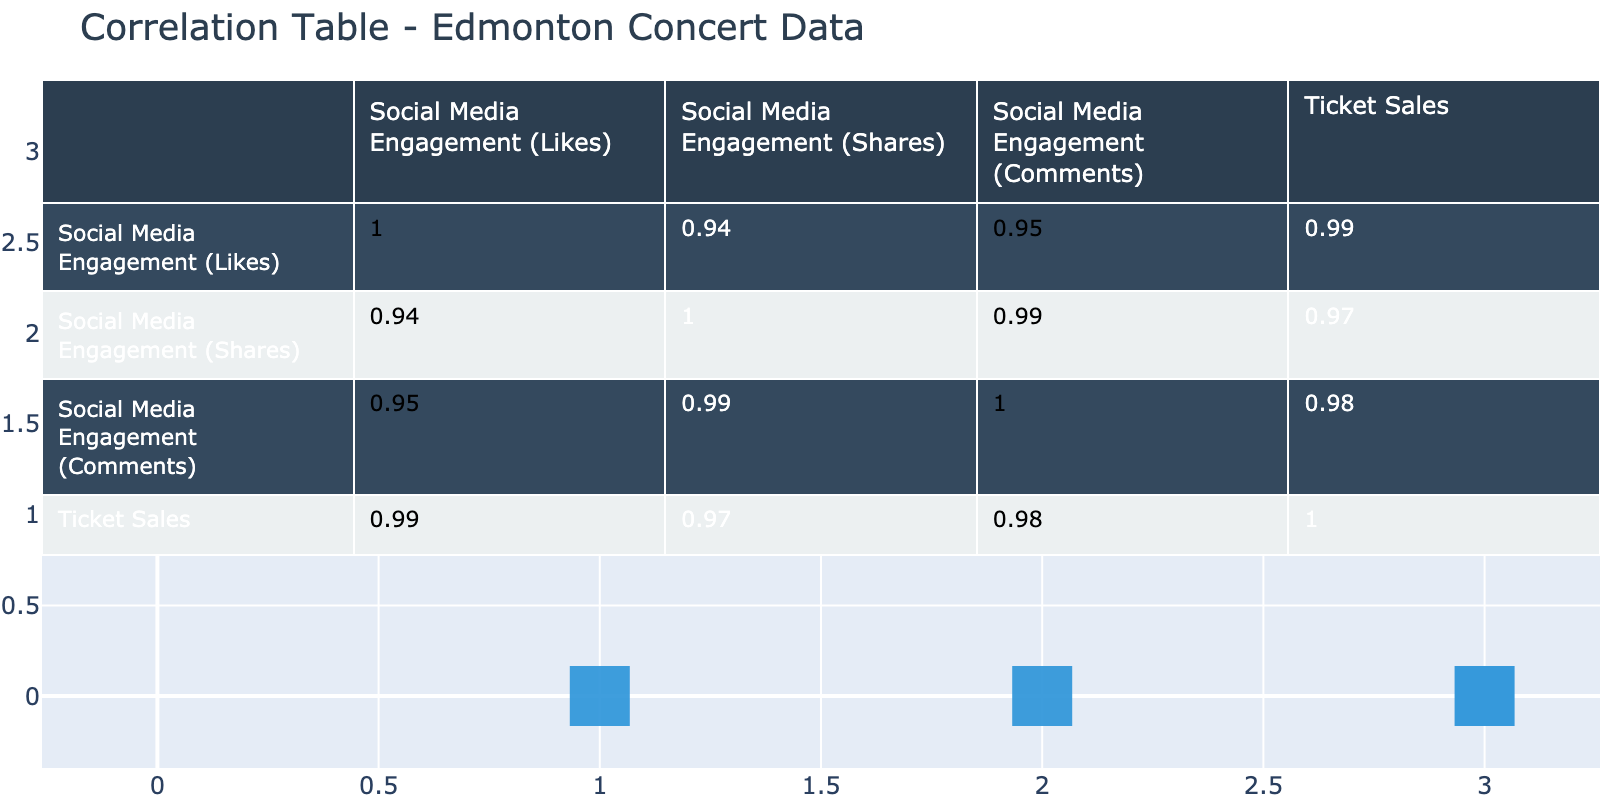What is the highest number of ticket sales in the table? The maximum value in the "Ticket Sales" column is 15000, which corresponds to the event "Trans-Siberian Orchestra."
Answer: 15000 Which event had the lowest social media engagement in likes? The event with the lowest "Social Media Engagement (Likes)" is "Edmonton Symphony Orchestra," with 800 likes.
Answer: Edmonton Symphony Orchestra What is the correlation coefficient between social media engagement comments and ticket sales? Based on the correlation table, the correlation coefficient between "Social Media Engagement (Comments)" and "Ticket Sales" is 0.96, indicating a strong positive correlation.
Answer: 0.96 Which event had the highest social media engagement in shares? The event with the highest "Social Media Engagement (Shares)" is "Trans-Siberian Orchestra," which had 600 shares.
Answer: Trans-Siberian Orchestra If we combine the social media engagement likes of "Dancing with the Stars Live" and "Edmonton Folk Music Festival," what is the total number of likes? Adding the likes of both events together, we calculate 1600 (Dancing with the Stars Live) + 1500 (Edmonton Folk Music Festival) = 3100 likes.
Answer: 3100 Is there a strong correlation between social media shares and ticket sales? Yes, the correlation coefficient between "Social Media Engagement (Shares)" and "Ticket Sales" is 0.94, which indicates a strong positive correlation.
Answer: Yes What is the average number of comments across all events? To find the average, sum all the comments: (200 + 180 + 350 + 100 + 280 + 400 + 150 + 500) = 1960, and divide by the number of events (8), resulting in an average of 245 comments.
Answer: 245 Which event has a lower social media engagement in likes: the Edmonton Folk Music Festival or the Shaw Conference Centre Concert? The Edmonton Folk Music Festival has 1500 likes, whereas the Shaw Conference Centre Concert has 1200 likes; thus, Shaw Conference has lower engagement.
Answer: Shaw Conference Centre Concert What is the total ticket sales for events with more than 1000 likes? The events with more than 1000 likes are "Edmonton Folk Music Festival," "Dancing with the Stars Live," "The Big Valley Jamboree," and "Trans-Siberian Orchestra." The total ticket sales for these events are: 7500 + 9000 + 11000 + 15000 = 43500.
Answer: 43500 